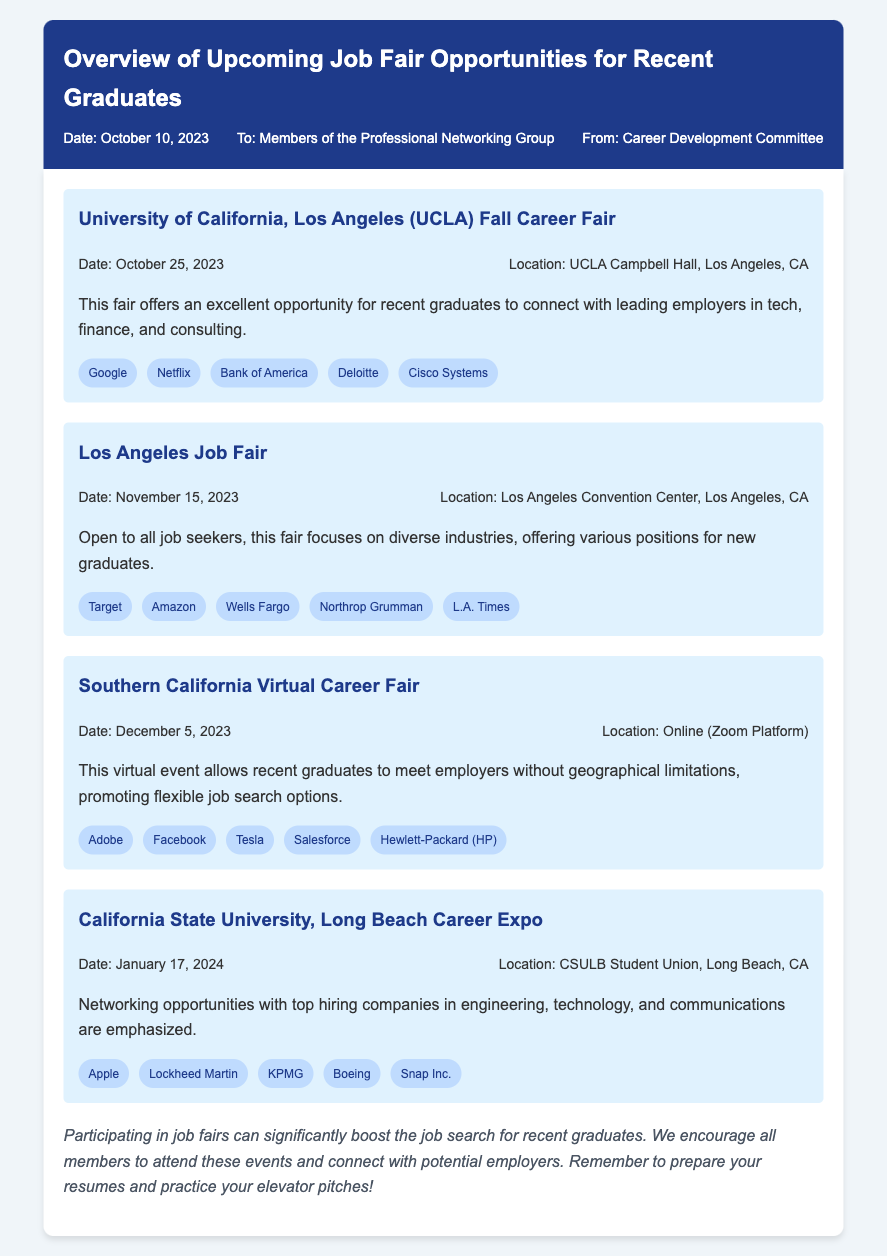What is the date of the UCLA Fall Career Fair? The document states that the UCLA Fall Career Fair is scheduled for October 25, 2023.
Answer: October 25, 2023 Where is the Los Angeles Job Fair being held? The location for the Los Angeles Job Fair is mentioned as the Los Angeles Convention Center, Los Angeles, CA.
Answer: Los Angeles Convention Center, Los Angeles, CA Which company is participating in the Southern California Virtual Career Fair? The document lists Adobe as one of the participating companies in the Southern California Virtual Career Fair.
Answer: Adobe What is the date of the California State University, Long Beach Career Expo? According to the document, the California State University, Long Beach Career Expo is on January 17, 2024.
Answer: January 17, 2024 How many companies are listed for the UCLA Fall Career Fair? The document lists five companies participating in the UCLA Fall Career Fair.
Answer: Five What is the format of the Southern California Virtual Career Fair? The document states that the Southern California Virtual Career Fair will take place online using the Zoom Platform.
Answer: Online (Zoom Platform) What advice is given for preparing for job fairs? The conclusion in the document advises to prepare resumes and practice elevator pitches for job fairs.
Answer: Prepare resumes and practice elevator pitches Which company is associated with engineering and technology hiring? The document mentions Boeing as one of the top hiring companies in engineering and technology at the California State University, Long Beach Career Expo.
Answer: Boeing 